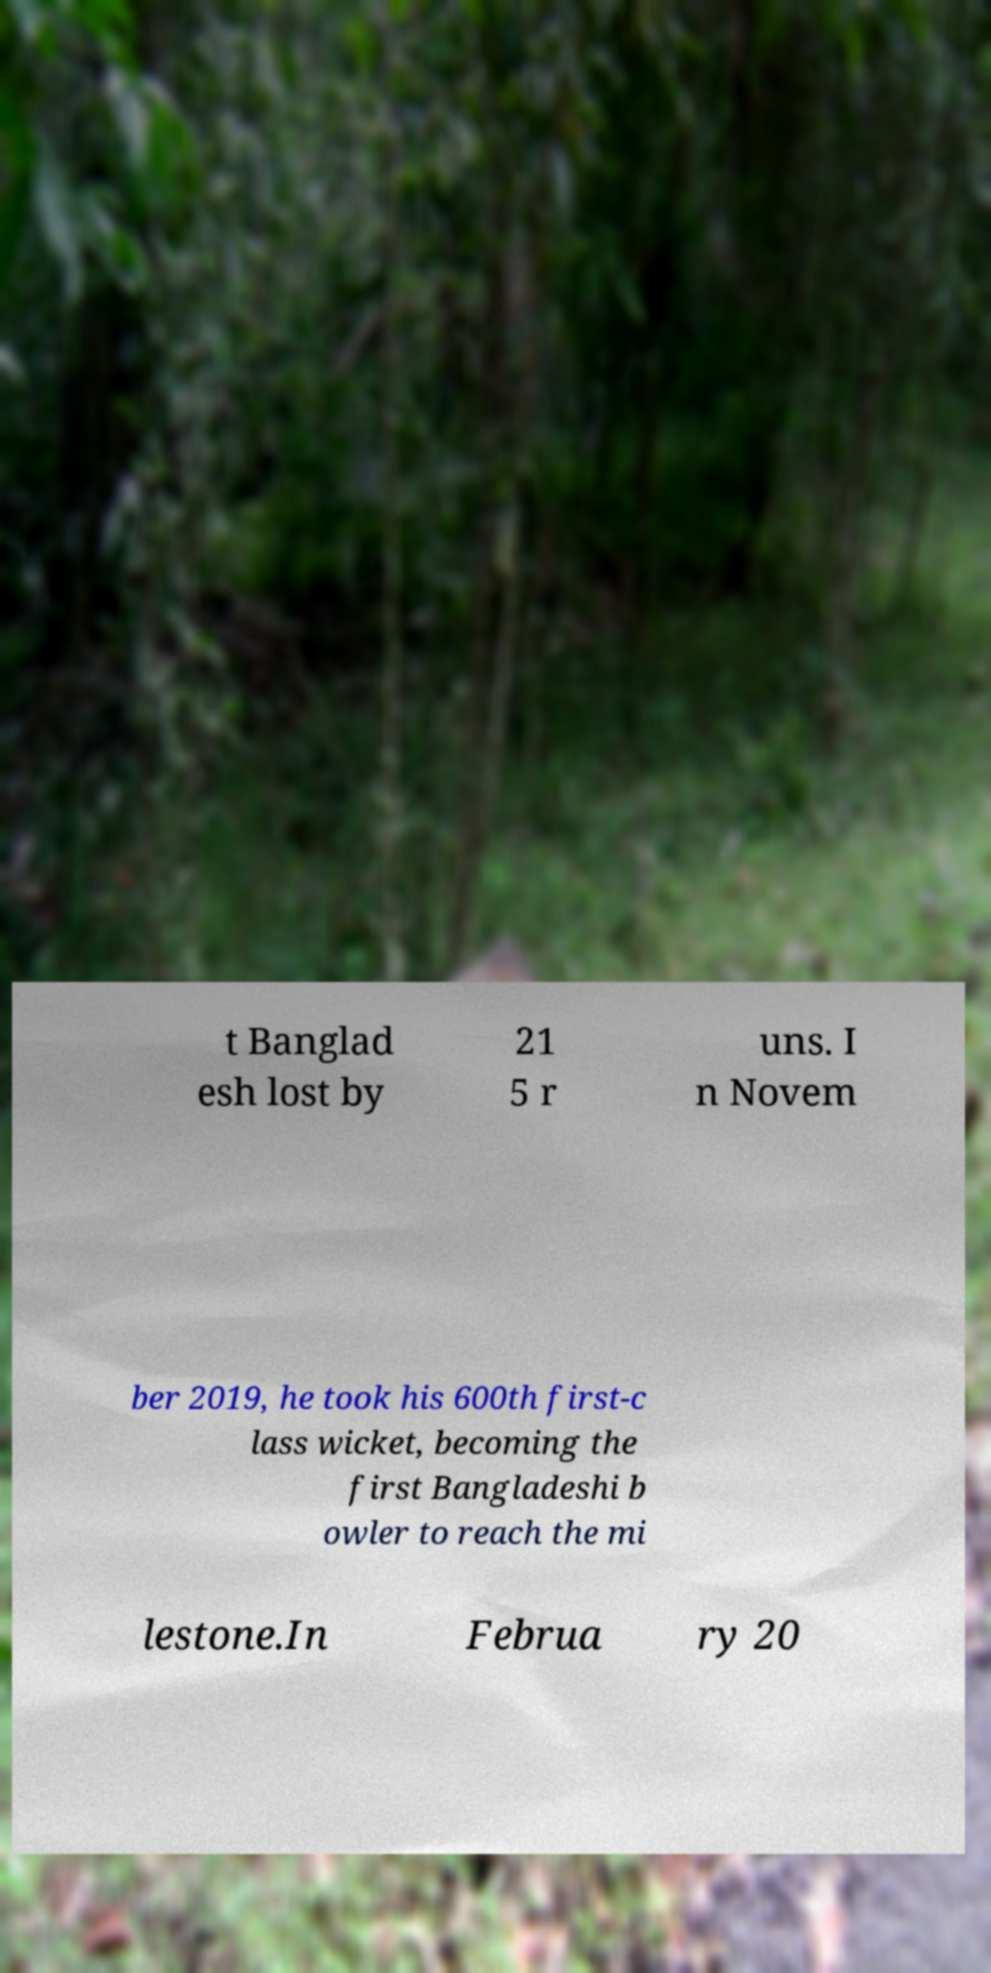Could you extract and type out the text from this image? t Banglad esh lost by 21 5 r uns. I n Novem ber 2019, he took his 600th first-c lass wicket, becoming the first Bangladeshi b owler to reach the mi lestone.In Februa ry 20 